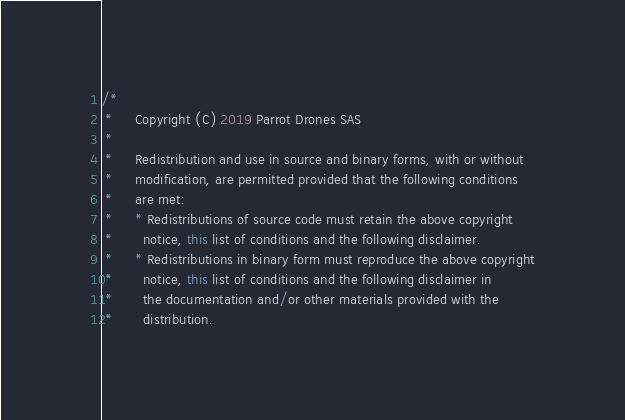Convert code to text. <code><loc_0><loc_0><loc_500><loc_500><_Java_>/*
 *     Copyright (C) 2019 Parrot Drones SAS
 *
 *     Redistribution and use in source and binary forms, with or without
 *     modification, are permitted provided that the following conditions
 *     are met:
 *     * Redistributions of source code must retain the above copyright
 *       notice, this list of conditions and the following disclaimer.
 *     * Redistributions in binary form must reproduce the above copyright
 *       notice, this list of conditions and the following disclaimer in
 *       the documentation and/or other materials provided with the
 *       distribution.</code> 